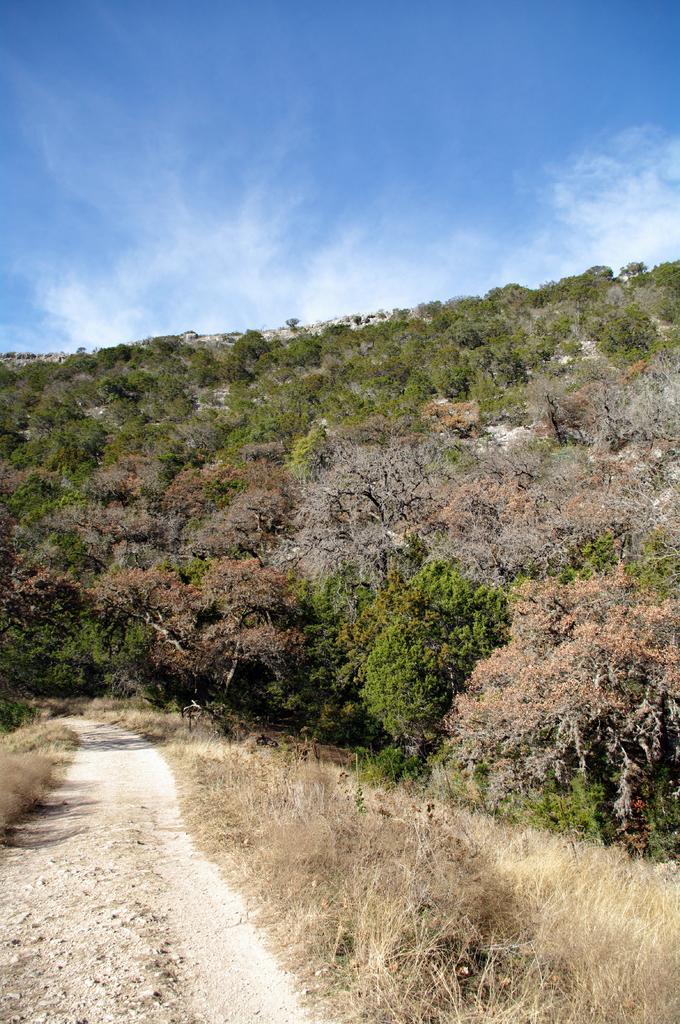Describe this image in one or two sentences. In this image we can see plants, trees, grass, stones, also we can see the sky. 